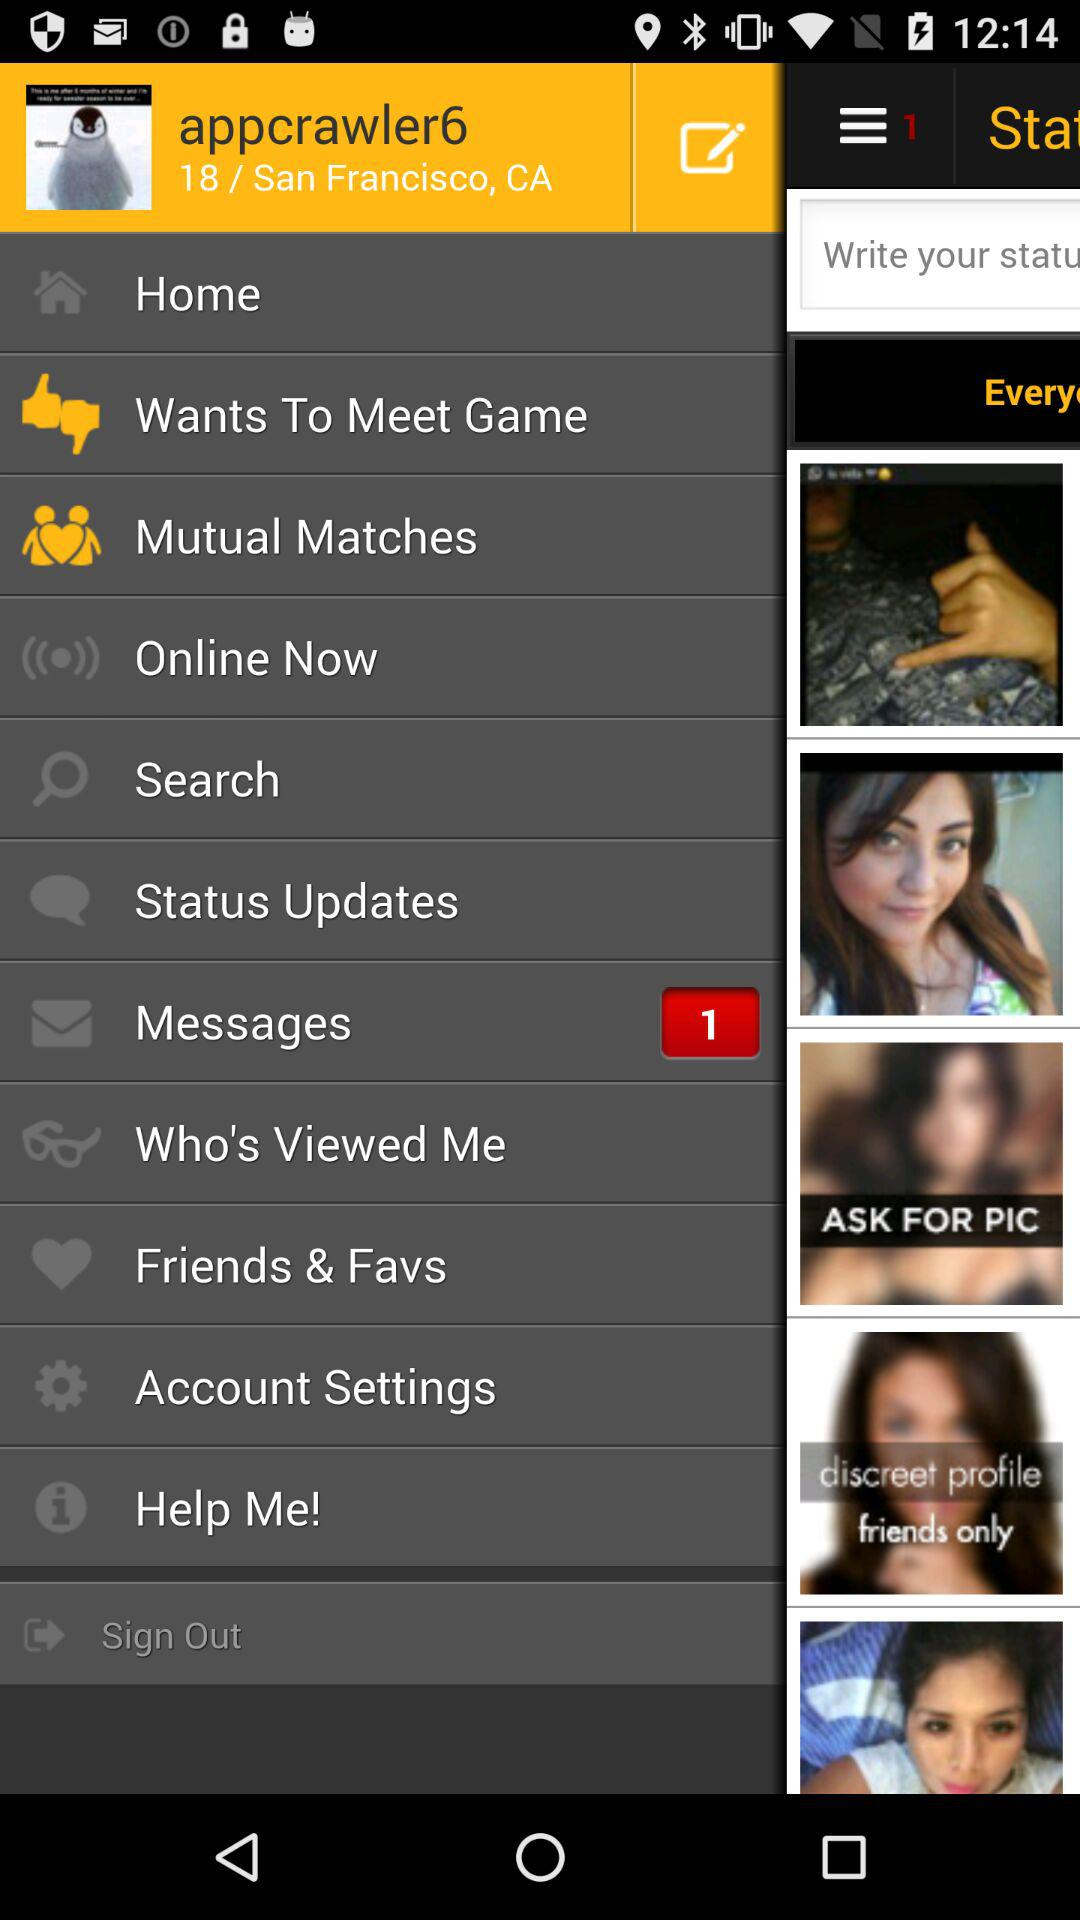What is the number of unread messages? The unread message is 1. 